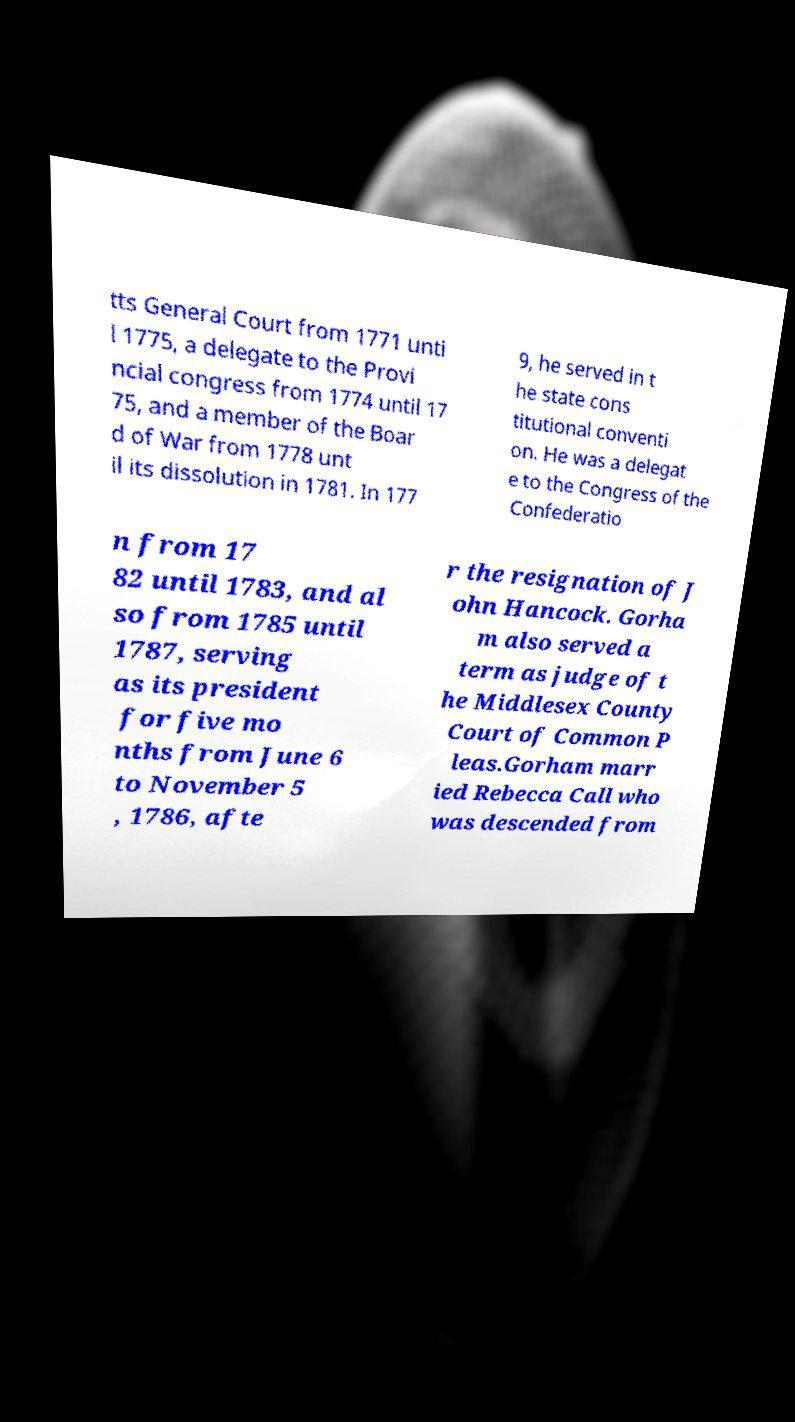Can you accurately transcribe the text from the provided image for me? tts General Court from 1771 unti l 1775, a delegate to the Provi ncial congress from 1774 until 17 75, and a member of the Boar d of War from 1778 unt il its dissolution in 1781. In 177 9, he served in t he state cons titutional conventi on. He was a delegat e to the Congress of the Confederatio n from 17 82 until 1783, and al so from 1785 until 1787, serving as its president for five mo nths from June 6 to November 5 , 1786, afte r the resignation of J ohn Hancock. Gorha m also served a term as judge of t he Middlesex County Court of Common P leas.Gorham marr ied Rebecca Call who was descended from 